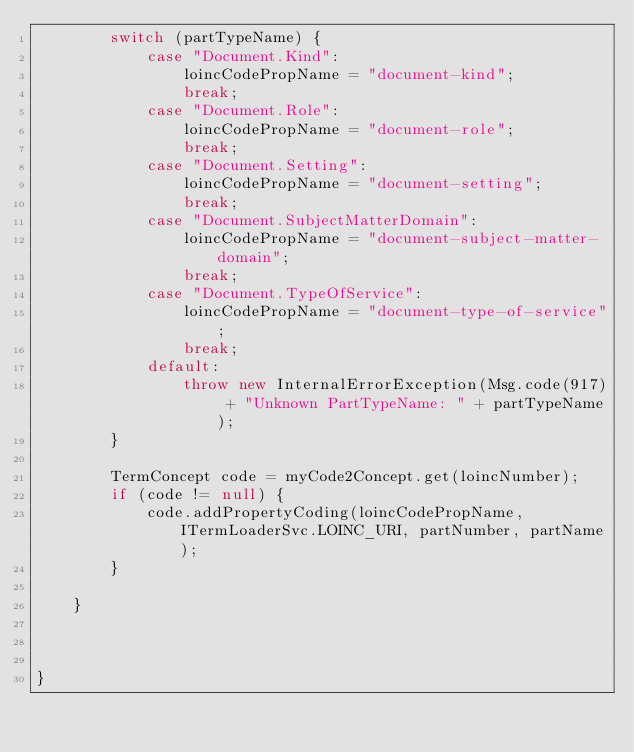Convert code to text. <code><loc_0><loc_0><loc_500><loc_500><_Java_>		switch (partTypeName) {
			case "Document.Kind":
				loincCodePropName = "document-kind";
				break;
			case "Document.Role":
				loincCodePropName = "document-role";
				break;
			case "Document.Setting":
				loincCodePropName = "document-setting";
				break;
			case "Document.SubjectMatterDomain":
				loincCodePropName = "document-subject-matter-domain";
				break;
			case "Document.TypeOfService":
				loincCodePropName = "document-type-of-service";
				break;
			default:
				throw new InternalErrorException(Msg.code(917) + "Unknown PartTypeName: " + partTypeName);
		}

		TermConcept code = myCode2Concept.get(loincNumber);
		if (code != null) {
			code.addPropertyCoding(loincCodePropName, ITermLoaderSvc.LOINC_URI, partNumber, partName);
		}

	}



}
</code> 